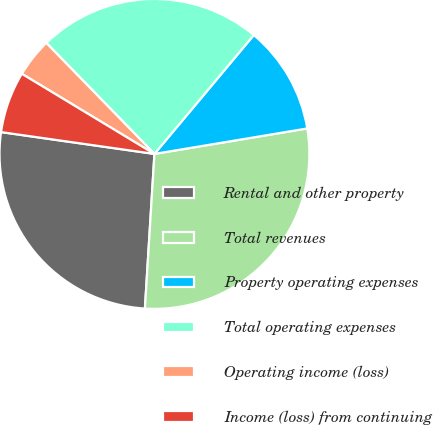<chart> <loc_0><loc_0><loc_500><loc_500><pie_chart><fcel>Rental and other property<fcel>Total revenues<fcel>Property operating expenses<fcel>Total operating expenses<fcel>Operating income (loss)<fcel>Income (loss) from continuing<nl><fcel>26.27%<fcel>28.61%<fcel>11.29%<fcel>23.37%<fcel>4.06%<fcel>6.4%<nl></chart> 